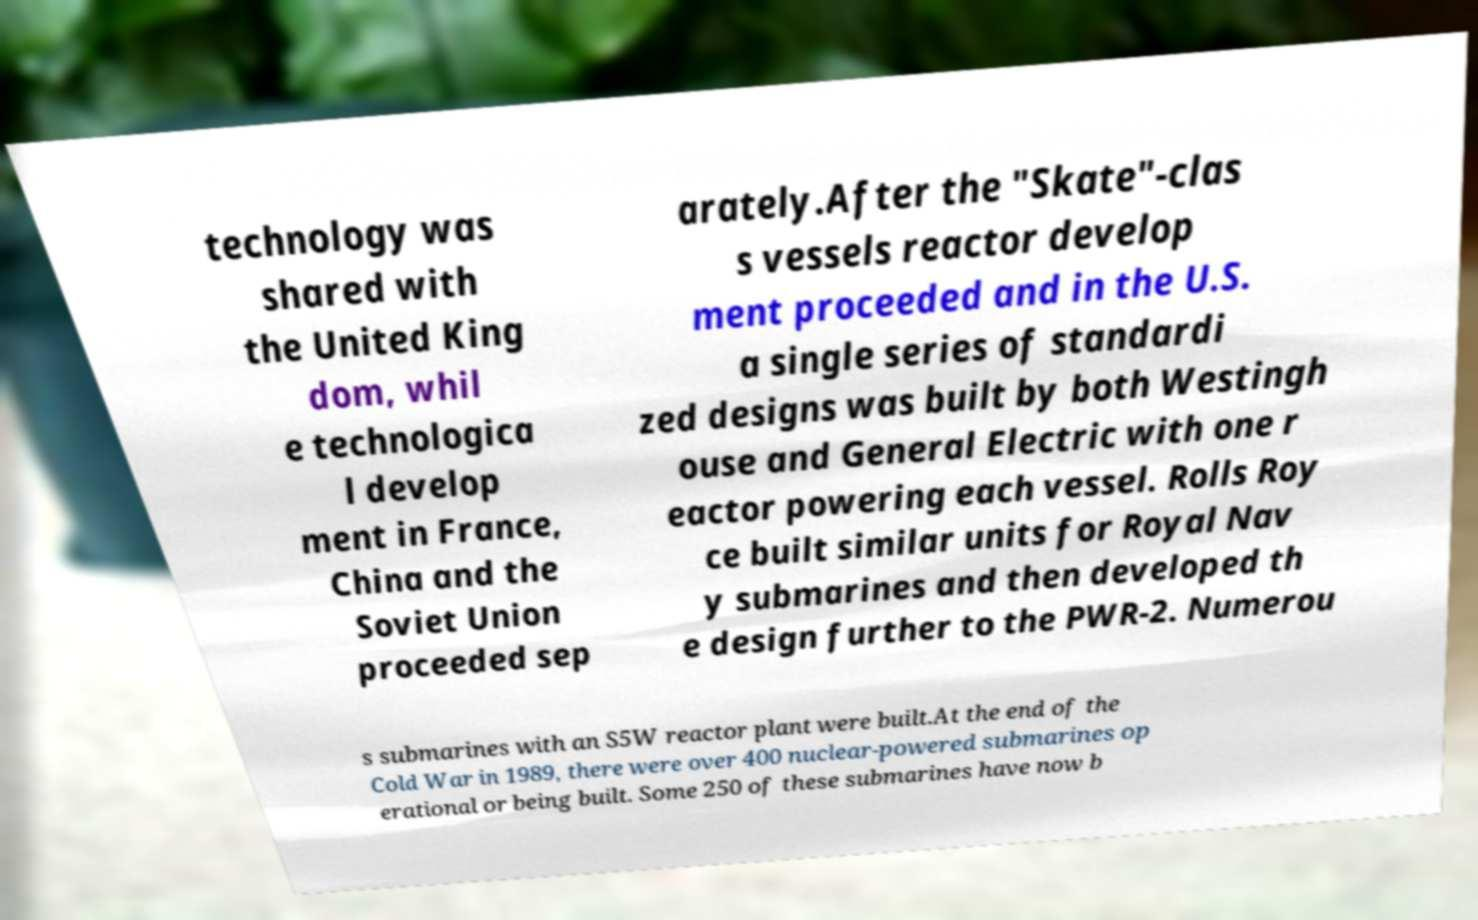Can you accurately transcribe the text from the provided image for me? technology was shared with the United King dom, whil e technologica l develop ment in France, China and the Soviet Union proceeded sep arately.After the "Skate"-clas s vessels reactor develop ment proceeded and in the U.S. a single series of standardi zed designs was built by both Westingh ouse and General Electric with one r eactor powering each vessel. Rolls Roy ce built similar units for Royal Nav y submarines and then developed th e design further to the PWR-2. Numerou s submarines with an S5W reactor plant were built.At the end of the Cold War in 1989, there were over 400 nuclear-powered submarines op erational or being built. Some 250 of these submarines have now b 